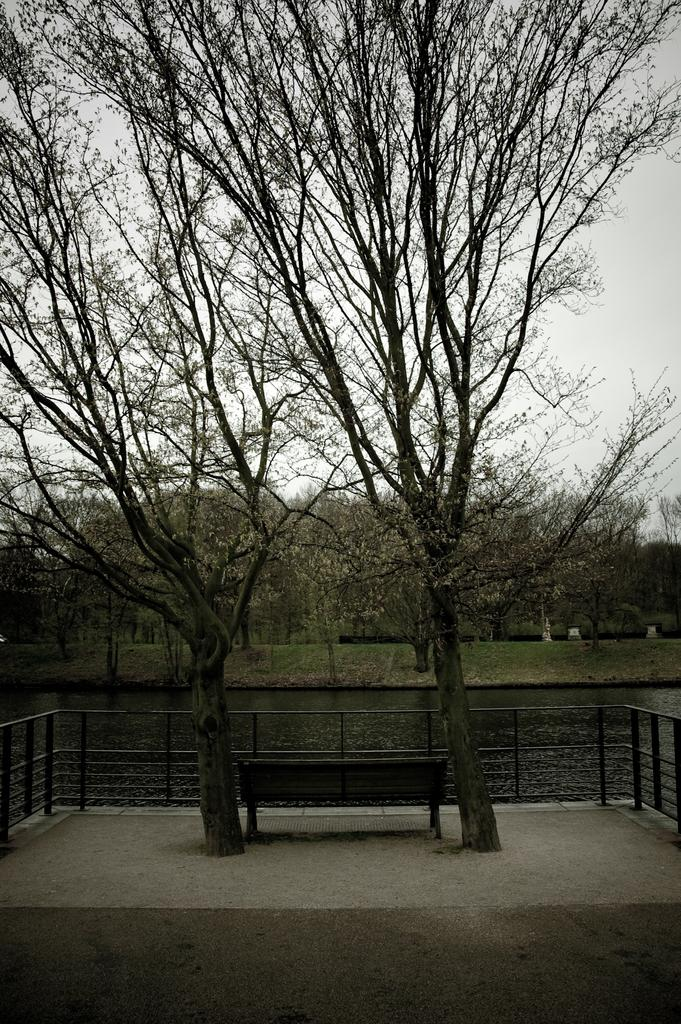How many trees can be seen in the image? There are two trees in the image. What is located between the trees? There is a bench between the trees. What type of structure is present in the image? There is a fence in the image. What can be seen in the background of the image? Water and trees on a grassland are visible in the background. What is visible at the top of the image? The sky is visible at the top of the image. How many lizards are sitting on the bench in the image? There are no lizards present in the image. What type of cord is used to connect the trees in the image? There is no cord connecting the trees in the image; the trees are separate entities. 